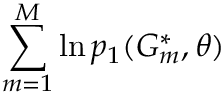Convert formula to latex. <formula><loc_0><loc_0><loc_500><loc_500>\sum _ { m = 1 } ^ { M } \ln p _ { 1 } ( G _ { m } ^ { * } , \theta )</formula> 